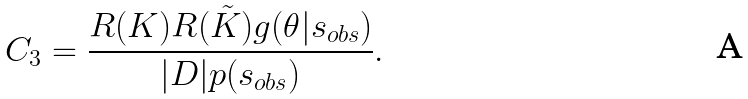Convert formula to latex. <formula><loc_0><loc_0><loc_500><loc_500>C _ { 3 } = \frac { R ( K ) R ( \tilde { K } ) g ( \theta | { s } _ { o b s } ) } { | D | p ( { s } _ { o b s } ) } .</formula> 